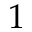Convert formula to latex. <formula><loc_0><loc_0><loc_500><loc_500>1</formula> 